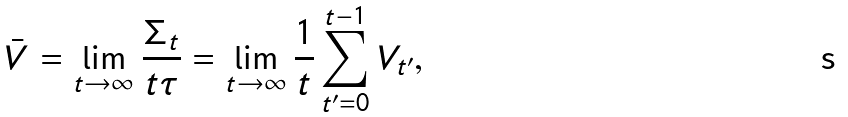<formula> <loc_0><loc_0><loc_500><loc_500>\bar { V } = \lim _ { t \to \infty } \frac { \Sigma _ { t } } { t \tau } = \lim _ { t \to \infty } \frac { 1 } { t } \sum _ { t ^ { \prime } = 0 } ^ { t - 1 } V _ { t ^ { \prime } } ,</formula> 